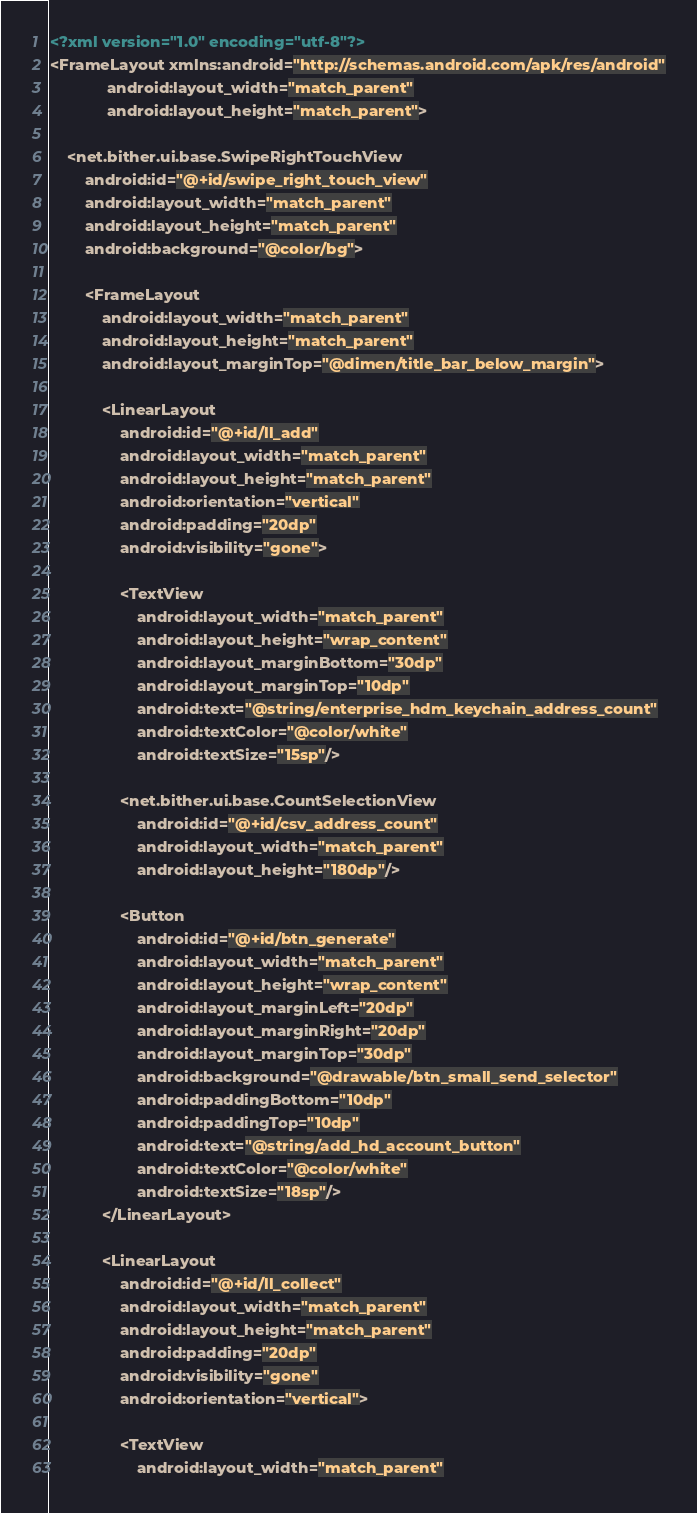Convert code to text. <code><loc_0><loc_0><loc_500><loc_500><_XML_><?xml version="1.0" encoding="utf-8"?>
<FrameLayout xmlns:android="http://schemas.android.com/apk/res/android"
             android:layout_width="match_parent"
             android:layout_height="match_parent">

    <net.bither.ui.base.SwipeRightTouchView
        android:id="@+id/swipe_right_touch_view"
        android:layout_width="match_parent"
        android:layout_height="match_parent"
        android:background="@color/bg">

        <FrameLayout
            android:layout_width="match_parent"
            android:layout_height="match_parent"
            android:layout_marginTop="@dimen/title_bar_below_margin">

            <LinearLayout
                android:id="@+id/ll_add"
                android:layout_width="match_parent"
                android:layout_height="match_parent"
                android:orientation="vertical"
                android:padding="20dp"
                android:visibility="gone">

                <TextView
                    android:layout_width="match_parent"
                    android:layout_height="wrap_content"
                    android:layout_marginBottom="30dp"
                    android:layout_marginTop="10dp"
                    android:text="@string/enterprise_hdm_keychain_address_count"
                    android:textColor="@color/white"
                    android:textSize="15sp"/>

                <net.bither.ui.base.CountSelectionView
                    android:id="@+id/csv_address_count"
                    android:layout_width="match_parent"
                    android:layout_height="180dp"/>

                <Button
                    android:id="@+id/btn_generate"
                    android:layout_width="match_parent"
                    android:layout_height="wrap_content"
                    android:layout_marginLeft="20dp"
                    android:layout_marginRight="20dp"
                    android:layout_marginTop="30dp"
                    android:background="@drawable/btn_small_send_selector"
                    android:paddingBottom="10dp"
                    android:paddingTop="10dp"
                    android:text="@string/add_hd_account_button"
                    android:textColor="@color/white"
                    android:textSize="18sp"/>
            </LinearLayout>

            <LinearLayout
                android:id="@+id/ll_collect"
                android:layout_width="match_parent"
                android:layout_height="match_parent"
                android:padding="20dp"
                android:visibility="gone"
                android:orientation="vertical">

                <TextView
                    android:layout_width="match_parent"</code> 